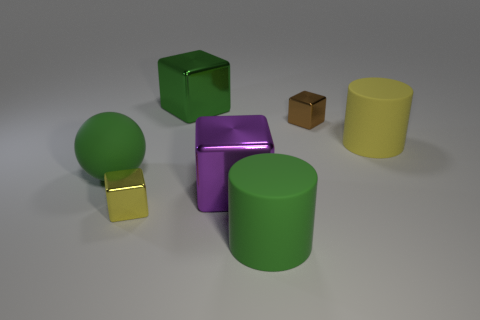Imagine these objects are part of a game. How might they be used? In an imaginative game scenario, each object could have a unique role. The green ball might be for throwing at targets, the green cube could be a player's home base, the yellow cylinder a tunnel to crawl through, the glossy purple cube a treasure to be discovered, and the small brown box a mystery item containing clues or bonuses. 